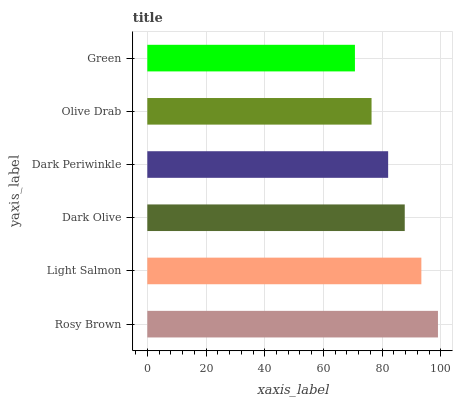Is Green the minimum?
Answer yes or no. Yes. Is Rosy Brown the maximum?
Answer yes or no. Yes. Is Light Salmon the minimum?
Answer yes or no. No. Is Light Salmon the maximum?
Answer yes or no. No. Is Rosy Brown greater than Light Salmon?
Answer yes or no. Yes. Is Light Salmon less than Rosy Brown?
Answer yes or no. Yes. Is Light Salmon greater than Rosy Brown?
Answer yes or no. No. Is Rosy Brown less than Light Salmon?
Answer yes or no. No. Is Dark Olive the high median?
Answer yes or no. Yes. Is Dark Periwinkle the low median?
Answer yes or no. Yes. Is Dark Periwinkle the high median?
Answer yes or no. No. Is Rosy Brown the low median?
Answer yes or no. No. 